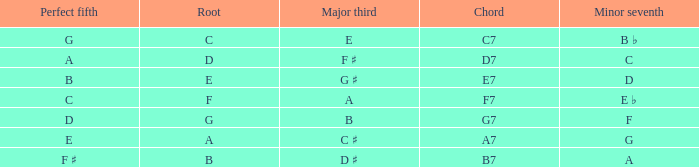What is the Major third with a Perfect fifth that is d? B. 